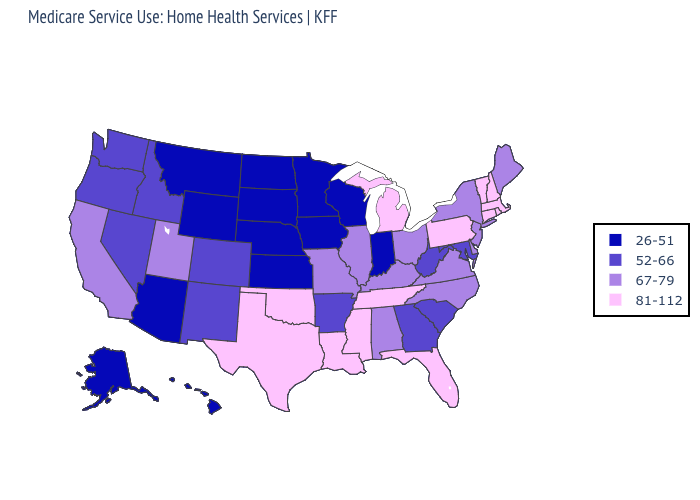What is the value of Nebraska?
Write a very short answer. 26-51. What is the lowest value in the USA?
Give a very brief answer. 26-51. Which states have the lowest value in the MidWest?
Be succinct. Indiana, Iowa, Kansas, Minnesota, Nebraska, North Dakota, South Dakota, Wisconsin. Which states have the lowest value in the Northeast?
Give a very brief answer. Maine, New Jersey, New York. Does Massachusetts have the highest value in the USA?
Answer briefly. Yes. Name the states that have a value in the range 52-66?
Concise answer only. Arkansas, Colorado, Georgia, Idaho, Maryland, Nevada, New Mexico, Oregon, South Carolina, Washington, West Virginia. What is the highest value in states that border Delaware?
Be succinct. 81-112. Which states have the highest value in the USA?
Short answer required. Connecticut, Florida, Louisiana, Massachusetts, Michigan, Mississippi, New Hampshire, Oklahoma, Pennsylvania, Rhode Island, Tennessee, Texas, Vermont. What is the value of Idaho?
Give a very brief answer. 52-66. Does North Dakota have the lowest value in the USA?
Keep it brief. Yes. Which states have the lowest value in the USA?
Answer briefly. Alaska, Arizona, Hawaii, Indiana, Iowa, Kansas, Minnesota, Montana, Nebraska, North Dakota, South Dakota, Wisconsin, Wyoming. What is the value of Georgia?
Quick response, please. 52-66. Name the states that have a value in the range 67-79?
Keep it brief. Alabama, California, Delaware, Illinois, Kentucky, Maine, Missouri, New Jersey, New York, North Carolina, Ohio, Utah, Virginia. Which states hav the highest value in the West?
Short answer required. California, Utah. What is the value of Massachusetts?
Give a very brief answer. 81-112. 